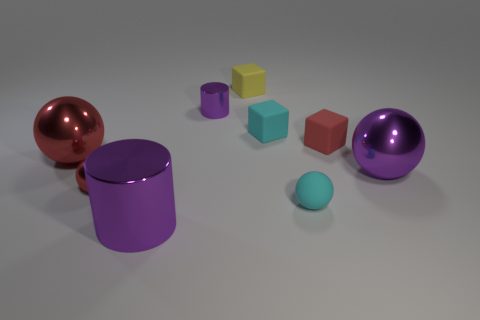Is the shape of the large red object the same as the tiny cyan thing that is in front of the purple metallic ball?
Offer a very short reply. Yes. There is a shiny cylinder behind the large purple cylinder; what is its size?
Give a very brief answer. Small. The purple thing that is both in front of the small cylinder and behind the large purple cylinder is made of what material?
Provide a short and direct response. Metal. There is a red matte thing right of the tiny thing that is in front of the red metal thing to the right of the large red metallic ball; what is its size?
Offer a terse response. Small. What is the size of the cyan thing that is made of the same material as the tiny cyan cube?
Give a very brief answer. Small. Is the size of the yellow matte cube the same as the cylinder that is in front of the large red metallic sphere?
Your answer should be compact. No. There is a big metal ball behind the purple object on the right side of the small yellow rubber thing; is there a red rubber object in front of it?
Your answer should be compact. No. What material is the other red thing that is the same shape as the large red metal object?
Offer a very short reply. Metal. What number of spheres are either red matte objects or red metallic things?
Offer a very short reply. 2. Is the size of the purple cylinder in front of the big red shiny sphere the same as the red thing that is right of the small yellow rubber block?
Provide a succinct answer. No. 